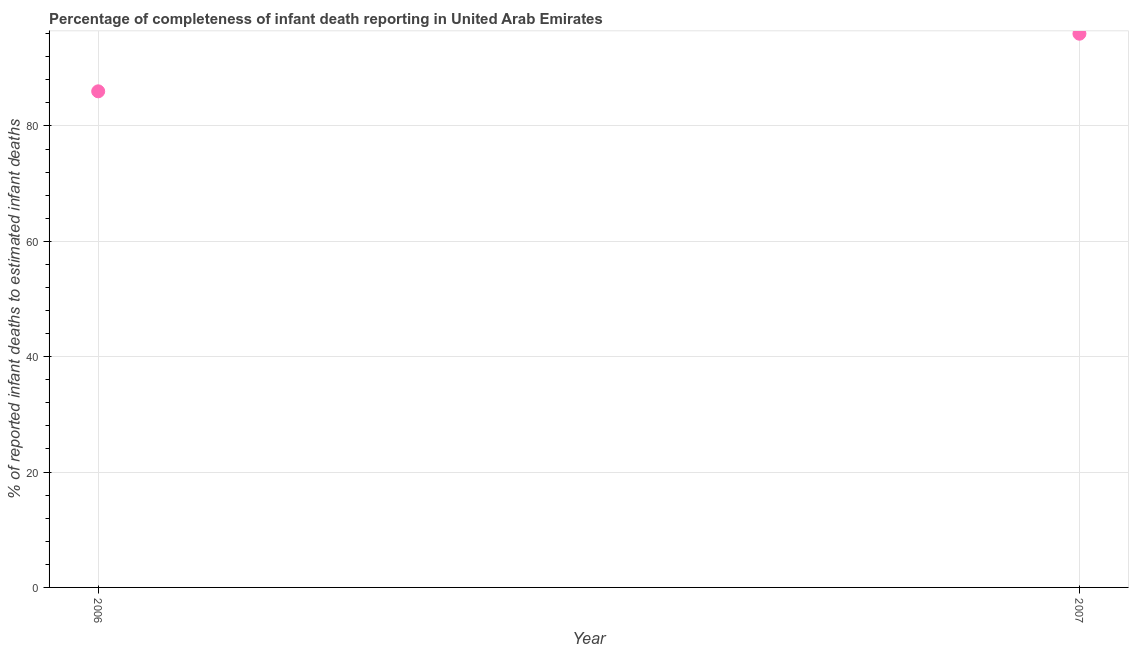What is the completeness of infant death reporting in 2007?
Make the answer very short. 96. Across all years, what is the maximum completeness of infant death reporting?
Offer a very short reply. 96. Across all years, what is the minimum completeness of infant death reporting?
Offer a terse response. 86.01. In which year was the completeness of infant death reporting minimum?
Your answer should be very brief. 2006. What is the sum of the completeness of infant death reporting?
Keep it short and to the point. 182.01. What is the difference between the completeness of infant death reporting in 2006 and 2007?
Your answer should be very brief. -9.99. What is the average completeness of infant death reporting per year?
Your answer should be very brief. 91.01. What is the median completeness of infant death reporting?
Provide a short and direct response. 91.01. Do a majority of the years between 2007 and 2006 (inclusive) have completeness of infant death reporting greater than 68 %?
Offer a very short reply. No. What is the ratio of the completeness of infant death reporting in 2006 to that in 2007?
Keep it short and to the point. 0.9. Is the completeness of infant death reporting in 2006 less than that in 2007?
Your answer should be very brief. Yes. In how many years, is the completeness of infant death reporting greater than the average completeness of infant death reporting taken over all years?
Give a very brief answer. 1. Does the completeness of infant death reporting monotonically increase over the years?
Offer a very short reply. Yes. How many dotlines are there?
Ensure brevity in your answer.  1. How many years are there in the graph?
Provide a short and direct response. 2. What is the difference between two consecutive major ticks on the Y-axis?
Your answer should be very brief. 20. What is the title of the graph?
Your answer should be compact. Percentage of completeness of infant death reporting in United Arab Emirates. What is the label or title of the Y-axis?
Provide a short and direct response. % of reported infant deaths to estimated infant deaths. What is the % of reported infant deaths to estimated infant deaths in 2006?
Your answer should be very brief. 86.01. What is the % of reported infant deaths to estimated infant deaths in 2007?
Keep it short and to the point. 96. What is the difference between the % of reported infant deaths to estimated infant deaths in 2006 and 2007?
Make the answer very short. -9.99. What is the ratio of the % of reported infant deaths to estimated infant deaths in 2006 to that in 2007?
Your answer should be very brief. 0.9. 